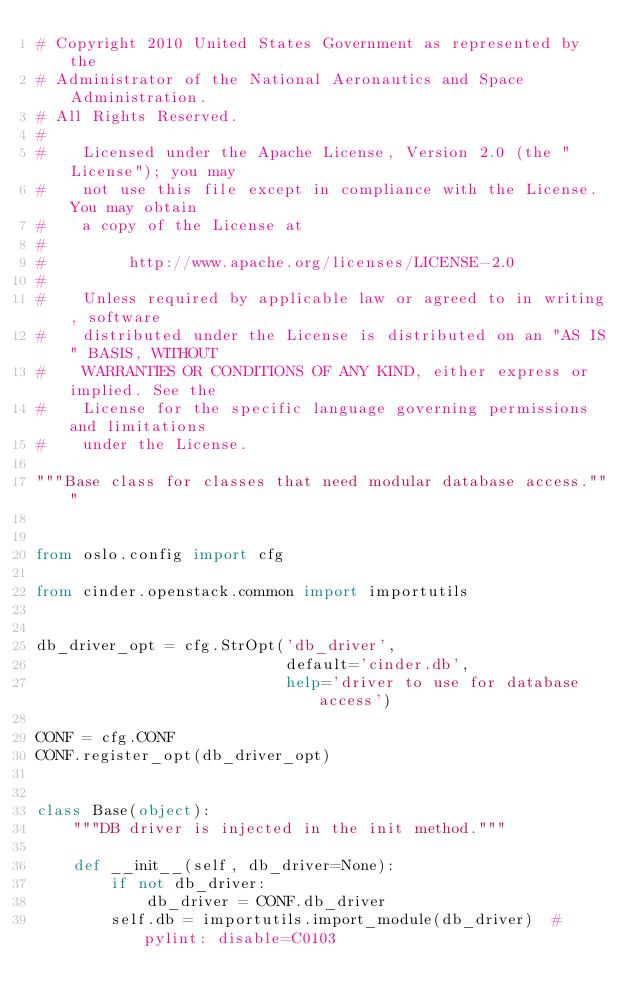<code> <loc_0><loc_0><loc_500><loc_500><_Python_># Copyright 2010 United States Government as represented by the
# Administrator of the National Aeronautics and Space Administration.
# All Rights Reserved.
#
#    Licensed under the Apache License, Version 2.0 (the "License"); you may
#    not use this file except in compliance with the License. You may obtain
#    a copy of the License at
#
#         http://www.apache.org/licenses/LICENSE-2.0
#
#    Unless required by applicable law or agreed to in writing, software
#    distributed under the License is distributed on an "AS IS" BASIS, WITHOUT
#    WARRANTIES OR CONDITIONS OF ANY KIND, either express or implied. See the
#    License for the specific language governing permissions and limitations
#    under the License.

"""Base class for classes that need modular database access."""


from oslo.config import cfg

from cinder.openstack.common import importutils


db_driver_opt = cfg.StrOpt('db_driver',
                           default='cinder.db',
                           help='driver to use for database access')

CONF = cfg.CONF
CONF.register_opt(db_driver_opt)


class Base(object):
    """DB driver is injected in the init method."""

    def __init__(self, db_driver=None):
        if not db_driver:
            db_driver = CONF.db_driver
        self.db = importutils.import_module(db_driver)  # pylint: disable=C0103
</code> 